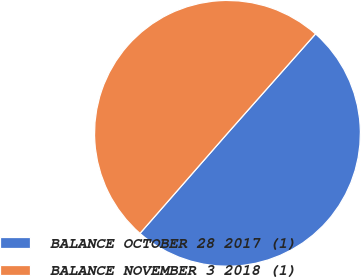Convert chart. <chart><loc_0><loc_0><loc_500><loc_500><pie_chart><fcel>BALANCE OCTOBER 28 2017 (1)<fcel>BALANCE NOVEMBER 3 2018 (1)<nl><fcel>49.9%<fcel>50.1%<nl></chart> 